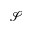Convert formula to latex. <formula><loc_0><loc_0><loc_500><loc_500>\mathcal { S }</formula> 